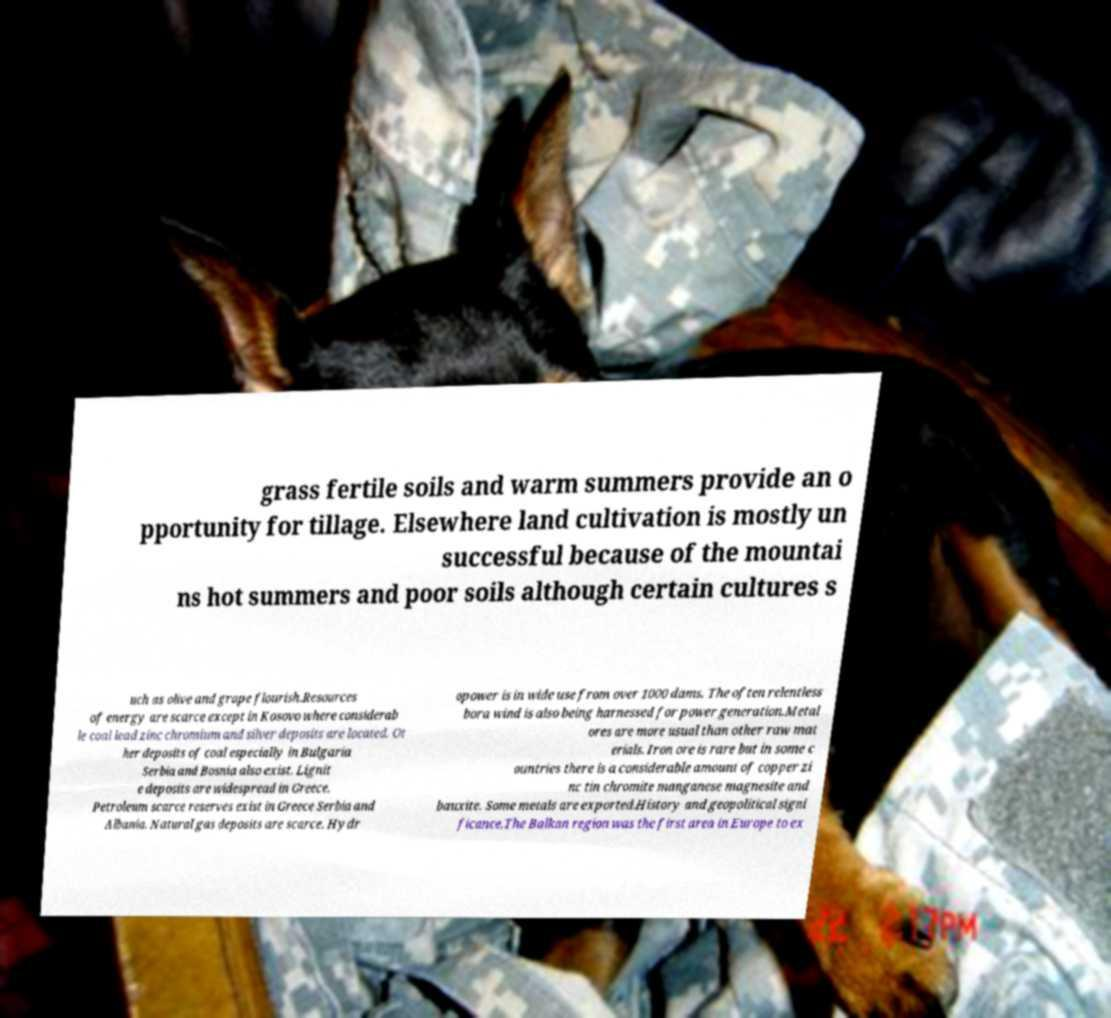Please read and relay the text visible in this image. What does it say? grass fertile soils and warm summers provide an o pportunity for tillage. Elsewhere land cultivation is mostly un successful because of the mountai ns hot summers and poor soils although certain cultures s uch as olive and grape flourish.Resources of energy are scarce except in Kosovo where considerab le coal lead zinc chromium and silver deposits are located. Ot her deposits of coal especially in Bulgaria Serbia and Bosnia also exist. Lignit e deposits are widespread in Greece. Petroleum scarce reserves exist in Greece Serbia and Albania. Natural gas deposits are scarce. Hydr opower is in wide use from over 1000 dams. The often relentless bora wind is also being harnessed for power generation.Metal ores are more usual than other raw mat erials. Iron ore is rare but in some c ountries there is a considerable amount of copper zi nc tin chromite manganese magnesite and bauxite. Some metals are exported.History and geopolitical signi ficance.The Balkan region was the first area in Europe to ex 